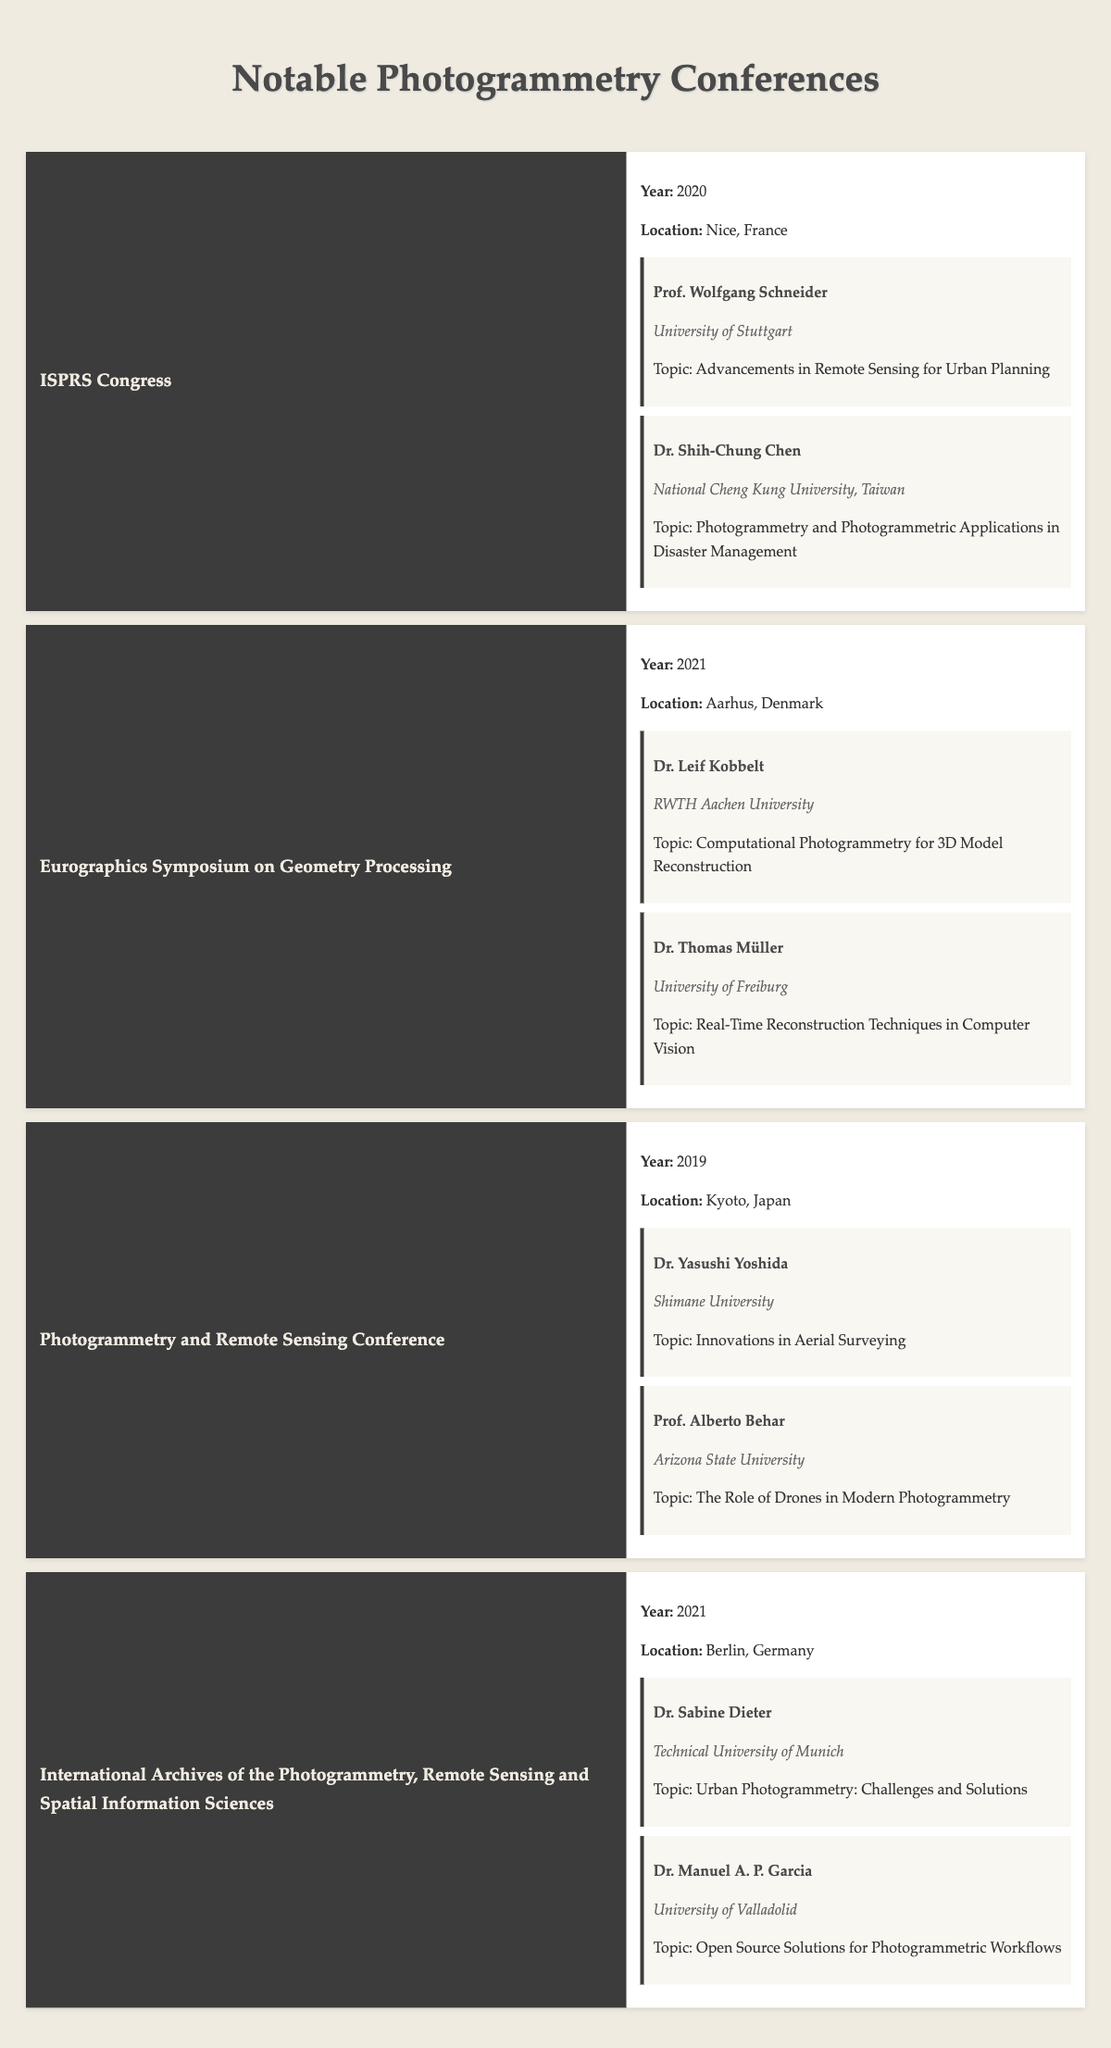What year did the ISPRS Congress take place? The ISPRS Congress is listed in the table with the year categorized under it. Referring to the entry for the ISPRS Congress, the year is mentioned as 2020.
Answer: 2020 Which conference was held in Berlin? The table presents multiple conferences along with their respective locations. By checking the locations, the conference mentioned in Berlin is the "International Archives of the Photogrammetry, Remote Sensing and Spatial Information Sciences."
Answer: International Archives of the Photogrammetry, Remote Sensing and Spatial Information Sciences How many conferences were held in 2021? Counting the listed conferences, the table indicates three conferences in 2021: "Eurographics Symposium on Geometry Processing," "International Archives of the Photogrammetry, Remote Sensing and Spatial Information Sciences," and another conference with the same year. Therefore, the total is three.
Answer: 2 Did any notable speaker at the Photogrammetry and Remote Sensing Conference focus on innovations in aerial surveying? Upon reviewing the speakers of the Photogrammetry and Remote Sensing Conference, Dr. Yasushi Yoshida is listed, and his topic is indeed "Innovations in Aerial Surveying."
Answer: Yes Which speaker from the Eurographics Symposium discussed real-time techniques? The Eurographics Symposium on Geometry Processing has two notable speakers. Referring to the list, Dr. Thomas Müller is the one who spoke on "Real-Time Reconstruction Techniques in Computer Vision."
Answer: Dr. Thomas Müller What are the affiliations of the notable speakers from the ISPRS Congress? The ISPRS Congress features two speakers: Prof. Wolfgang Schneider, affiliated with the University of Stuttgart, and Dr. Shih-Chung Chen, affiliated with National Cheng Kung University, Taiwan.
Answer: University of Stuttgart, National Cheng Kung University, Taiwan How many topics did Dr. Manuel A. P. Garcia cover in the conferences listed? The table only mentions Dr. Manuel A. P. Garcia appearing in one conference, the International Archives of the Photogrammetry, Remote Sensing and Spatial Information Sciences, where he discussed “Open Source Solutions for Photogrammetric Workflows.” Hence, he covered one topic.
Answer: 1 In total, how many unique years are represented in the table? Analyzing the years listed, there are three unique years showcased: 2019 (Photogrammetry and Remote Sensing Conference), 2020 (ISPRS Congress), and 2021 (two conferences). Thus there are three distinct years.
Answer: 3 